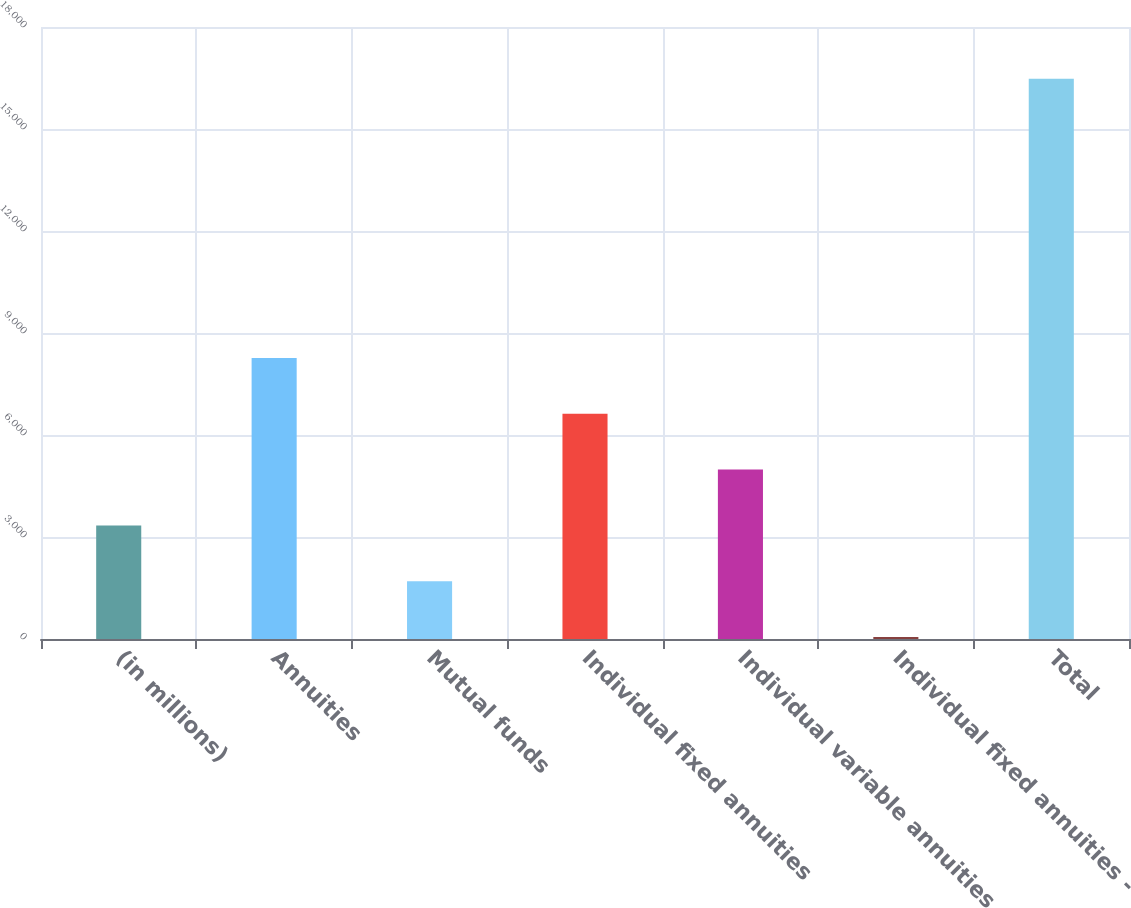Convert chart. <chart><loc_0><loc_0><loc_500><loc_500><bar_chart><fcel>(in millions)<fcel>Annuities<fcel>Mutual funds<fcel>Individual fixed annuities<fcel>Individual variable annuities<fcel>Individual fixed annuities -<fcel>Total<nl><fcel>3340.2<fcel>8266.5<fcel>1698.1<fcel>6624.4<fcel>4982.3<fcel>56<fcel>16477<nl></chart> 